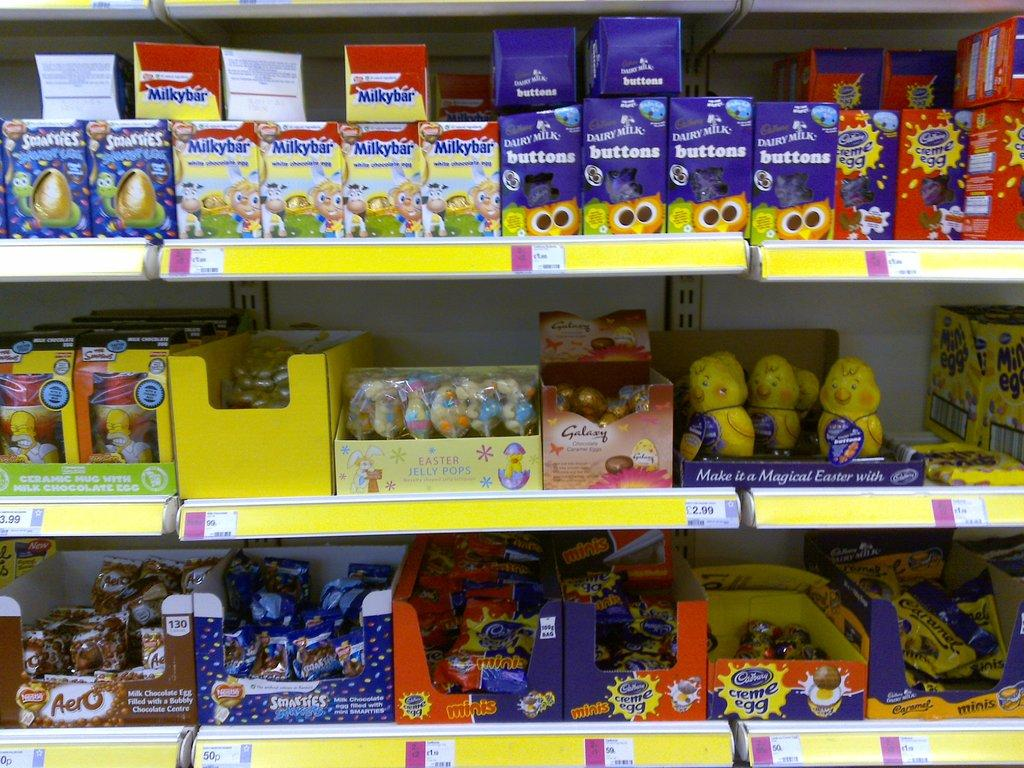What type of storage units are present in the image? There are shelves in the image. What can be found on the shelves? There are food items on the shelves. How can the food items be identified? Each food item has a label. What information is provided about the cost of the food items? There are price tags on the shelves. Can you see a veil covering any of the food items in the image? No, there is no veil present in the image. How is the string used in the image? There is no string present in the image. 